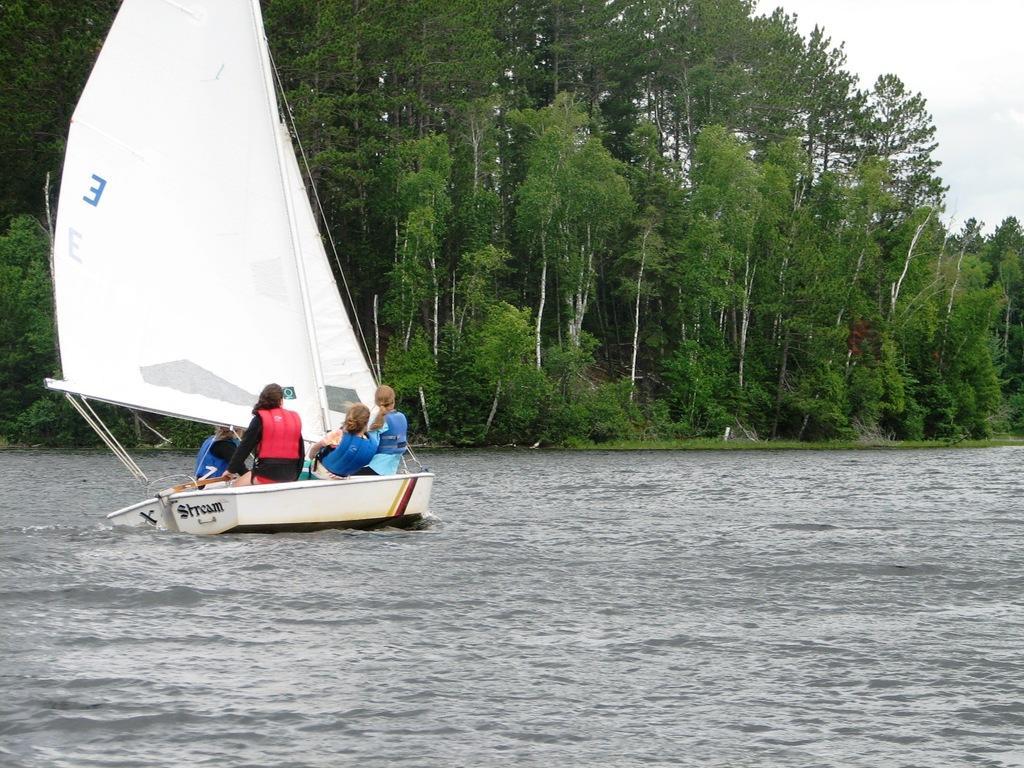In one or two sentences, can you explain what this image depicts? On the left side, there are persons in two white color boats, which are on the water. In the background, there are trees, plants and there are clouds in the sky. 